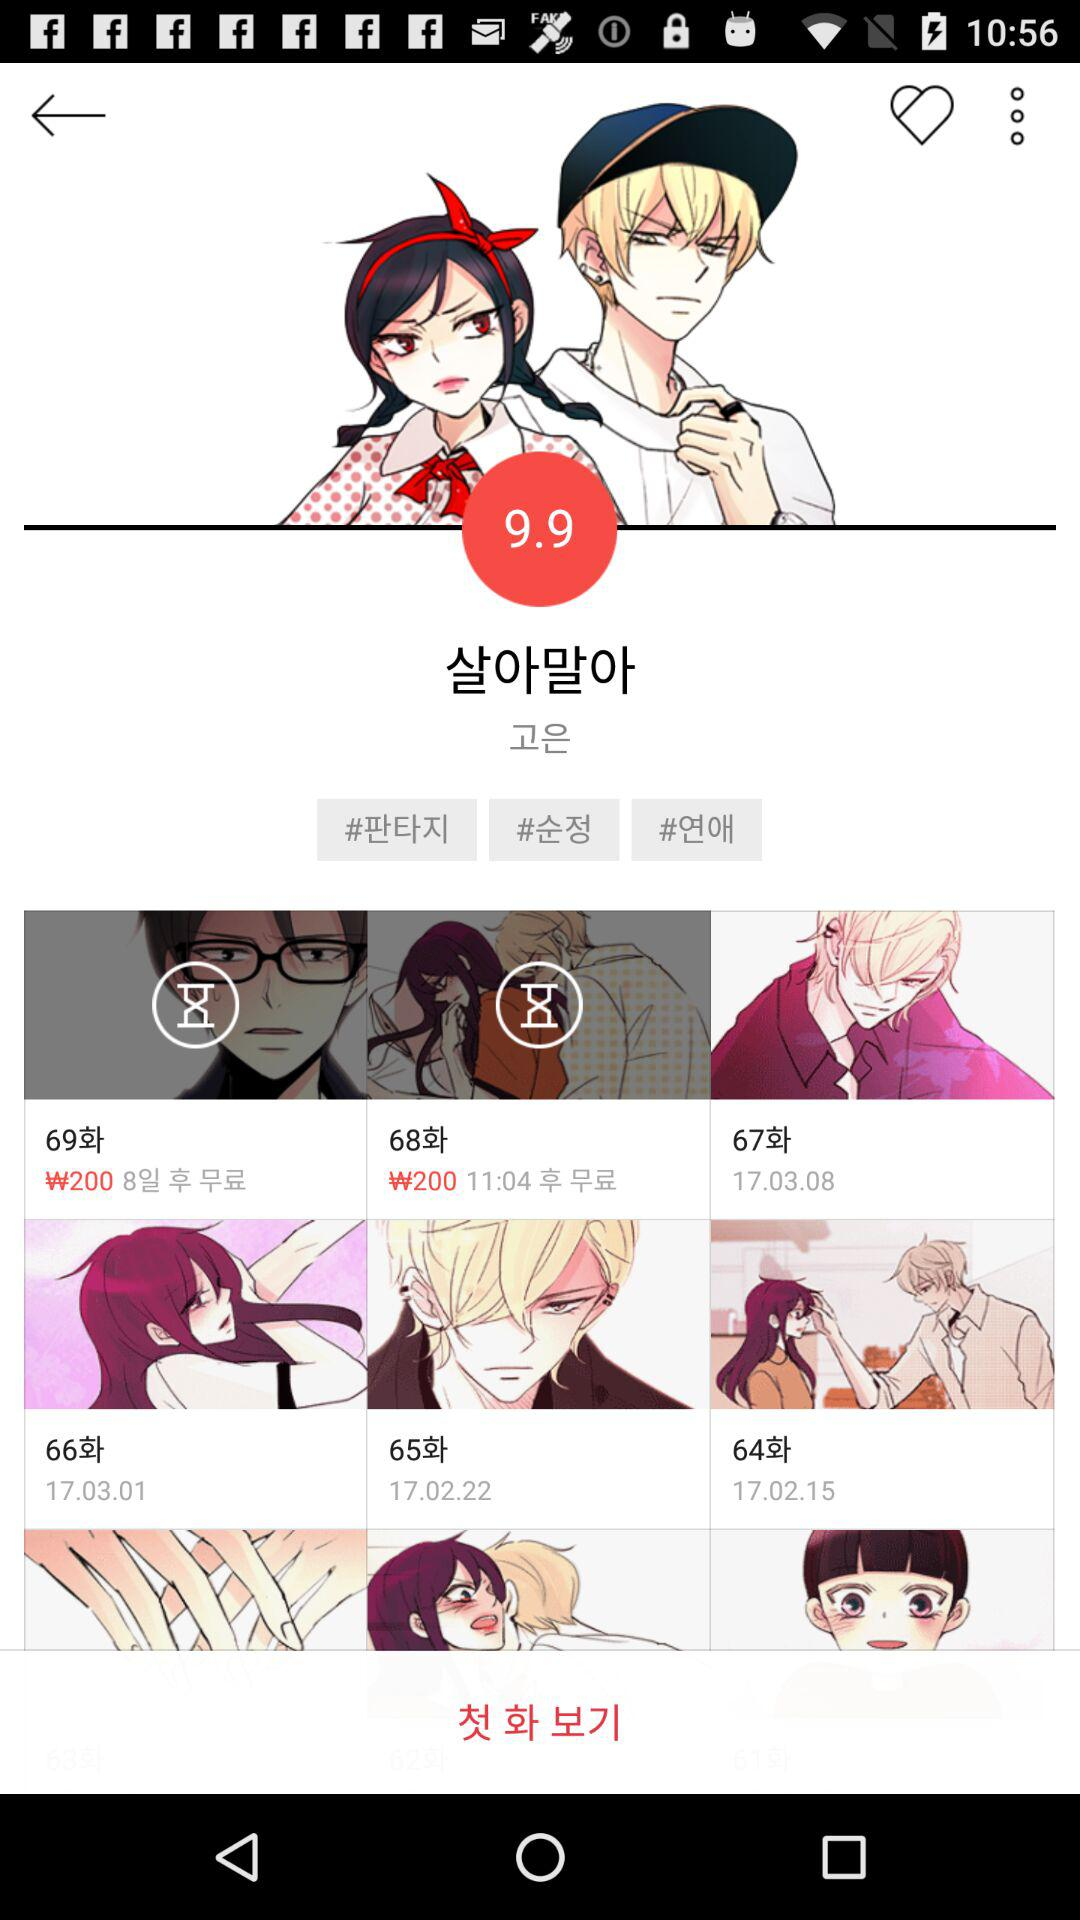How many episodes are there in the series?
Answer the question using a single word or phrase. 69 